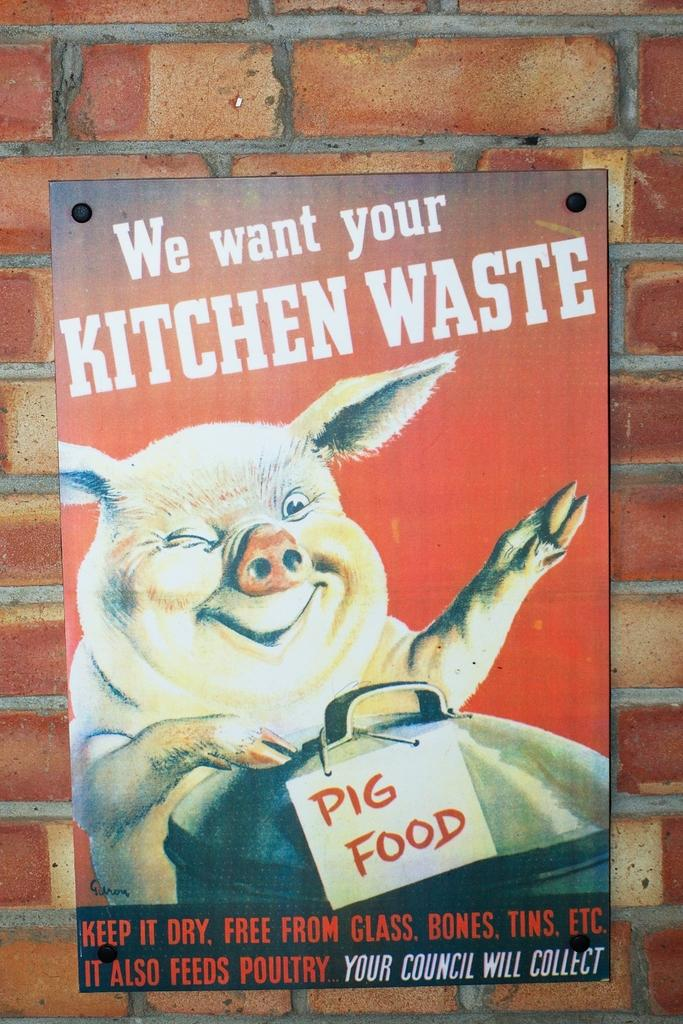What is on the wall in the image? There is a poster on the wall in the image. What type of animal can be seen in the image? There is an animal depicted in the image. What object is present in the image that can hold or store items? There is a container present in the image. What type of structure is visible in the background of the image? There is no structure visible in the background of the image. What holiday is being celebrated in the image? There is no indication of a holiday being celebrated in the image. 